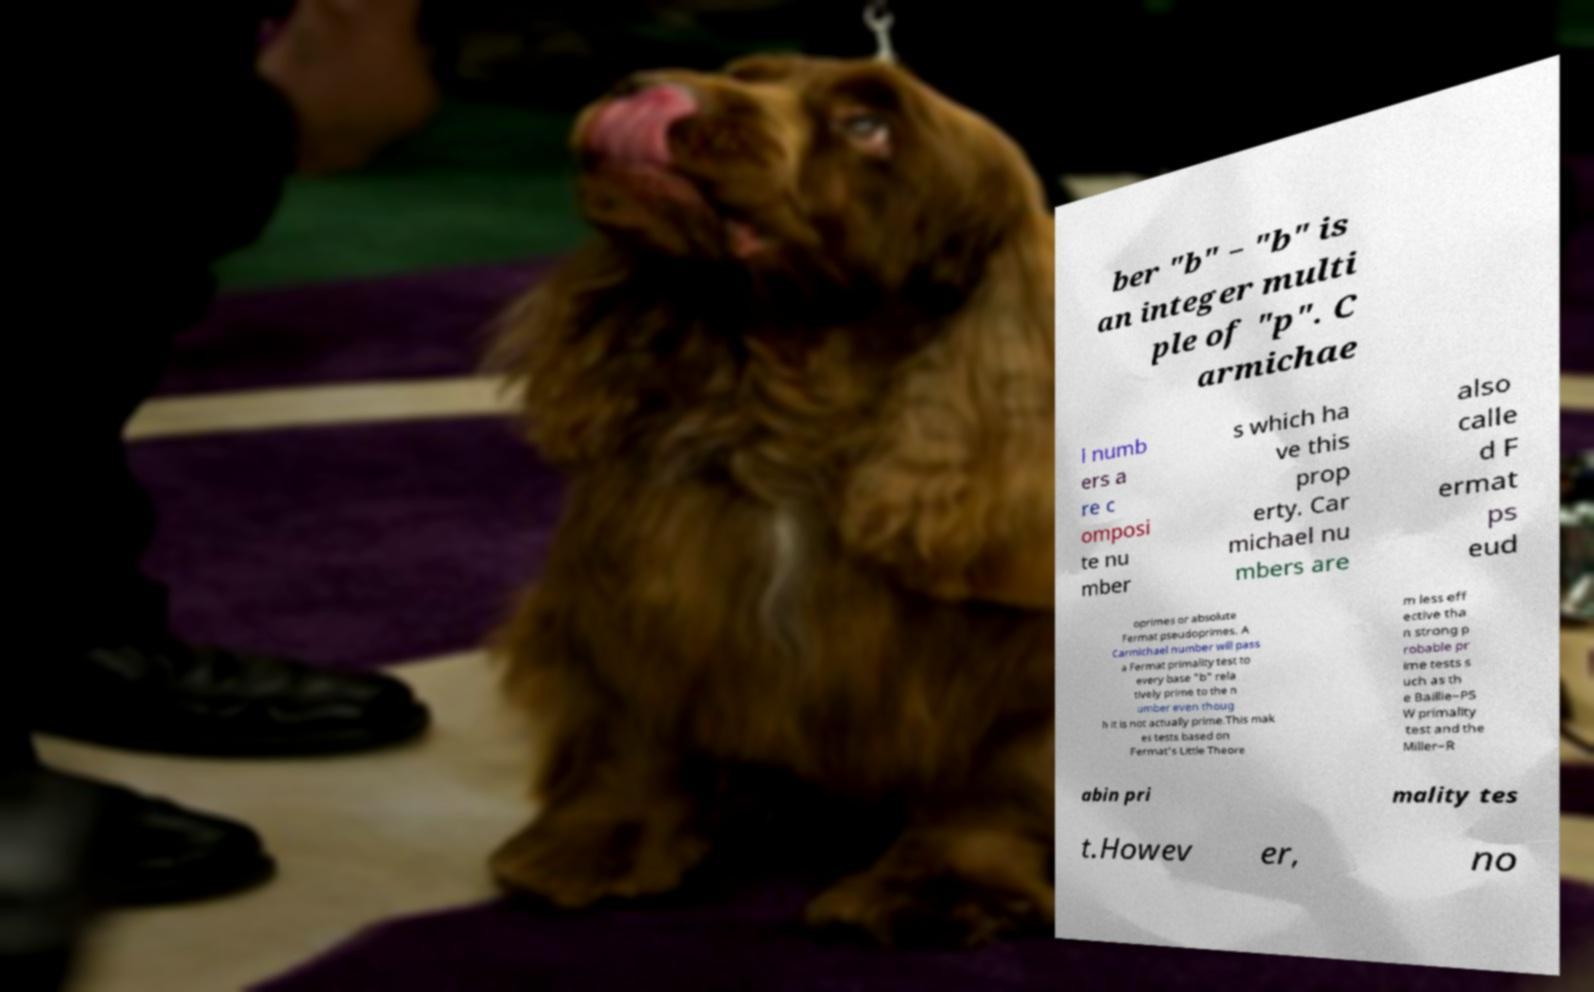What messages or text are displayed in this image? I need them in a readable, typed format. ber "b" − "b" is an integer multi ple of "p". C armichae l numb ers a re c omposi te nu mber s which ha ve this prop erty. Car michael nu mbers are also calle d F ermat ps eud oprimes or absolute Fermat pseudoprimes. A Carmichael number will pass a Fermat primality test to every base "b" rela tively prime to the n umber even thoug h it is not actually prime.This mak es tests based on Fermat's Little Theore m less eff ective tha n strong p robable pr ime tests s uch as th e Baillie–PS W primality test and the Miller–R abin pri mality tes t.Howev er, no 